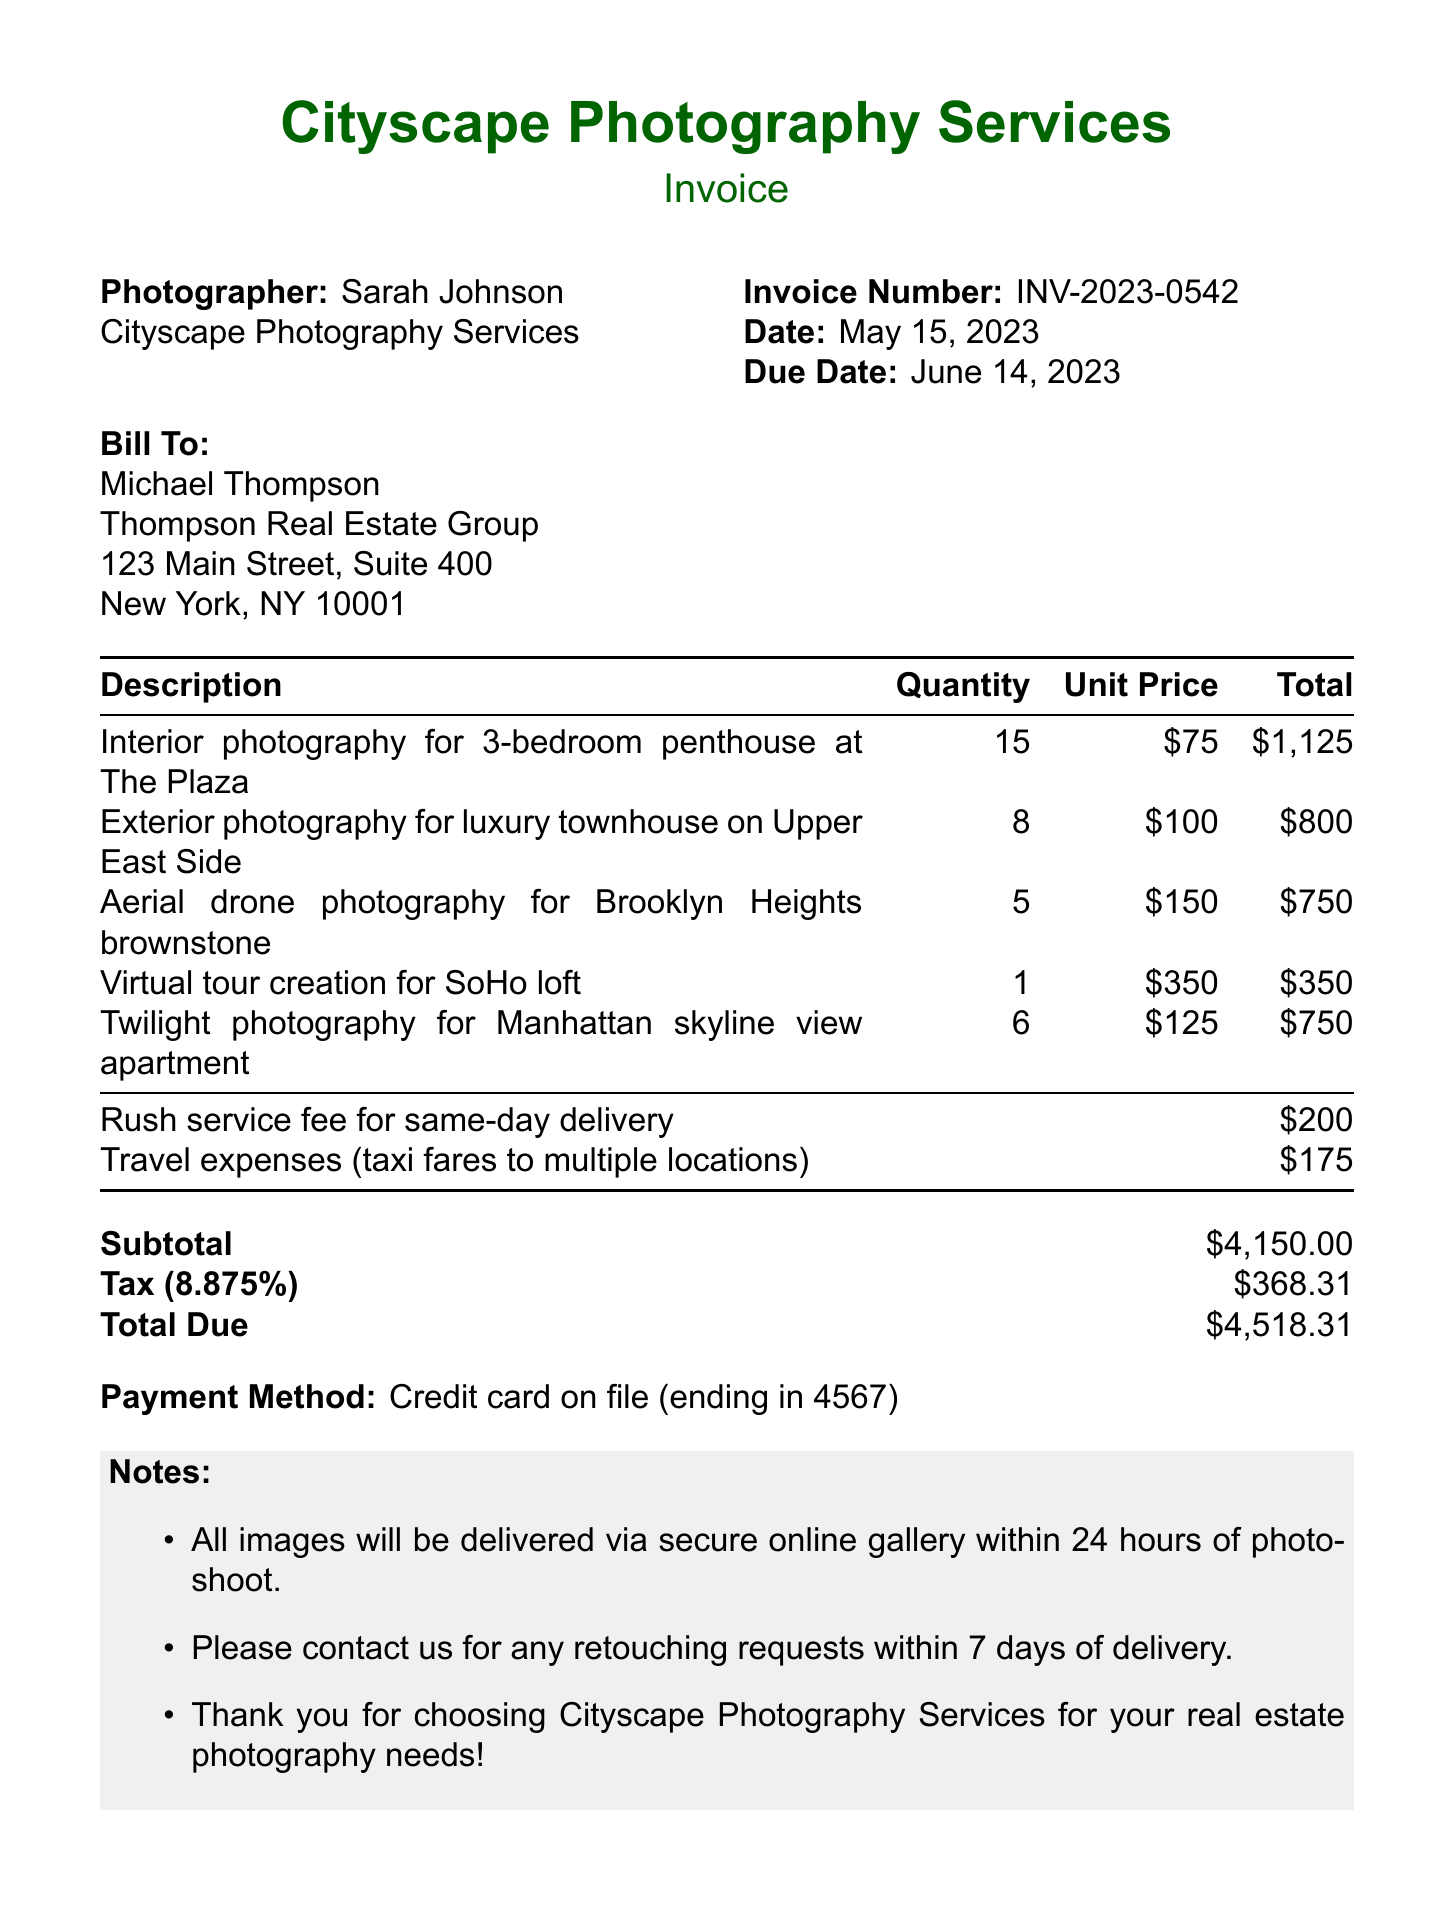What is the invoice number? The invoice number is listed under the invoice details section, which states "INV-2023-0542."
Answer: INV-2023-0542 Who is the photographer's name? The photographer's name is mentioned in the invoice details, which states "Sarah Johnson."
Answer: Sarah Johnson What is the subtotal amount? The subtotal amount is provided at the bottom of the itemized list and is "4150."
Answer: 4150 How many services were provided in total? The total number of services can be calculated by counting the itemized services listed; there are five services.
Answer: 5 What is the due date for payment? The due date for payment is specified in the invoice details as "June 14, 2023."
Answer: June 14, 2023 What is the total amount due? The total amount due is included at the end of the payment information section, which shows "$4518.31."
Answer: 4518.31 What is included in the notes? The notes section lists three specific items related to the deliverables and service agreement.
Answer: Delivery and retouching information What is the tax rate applied? The tax rate is mentioned in the payment information section as "8.875%."
Answer: 8.875% What additional charge is associated with same-day delivery? The specific additional charge for same-day delivery is explicitly stated as "Rush service fee for same-day delivery."
Answer: Rush service fee for same-day delivery 